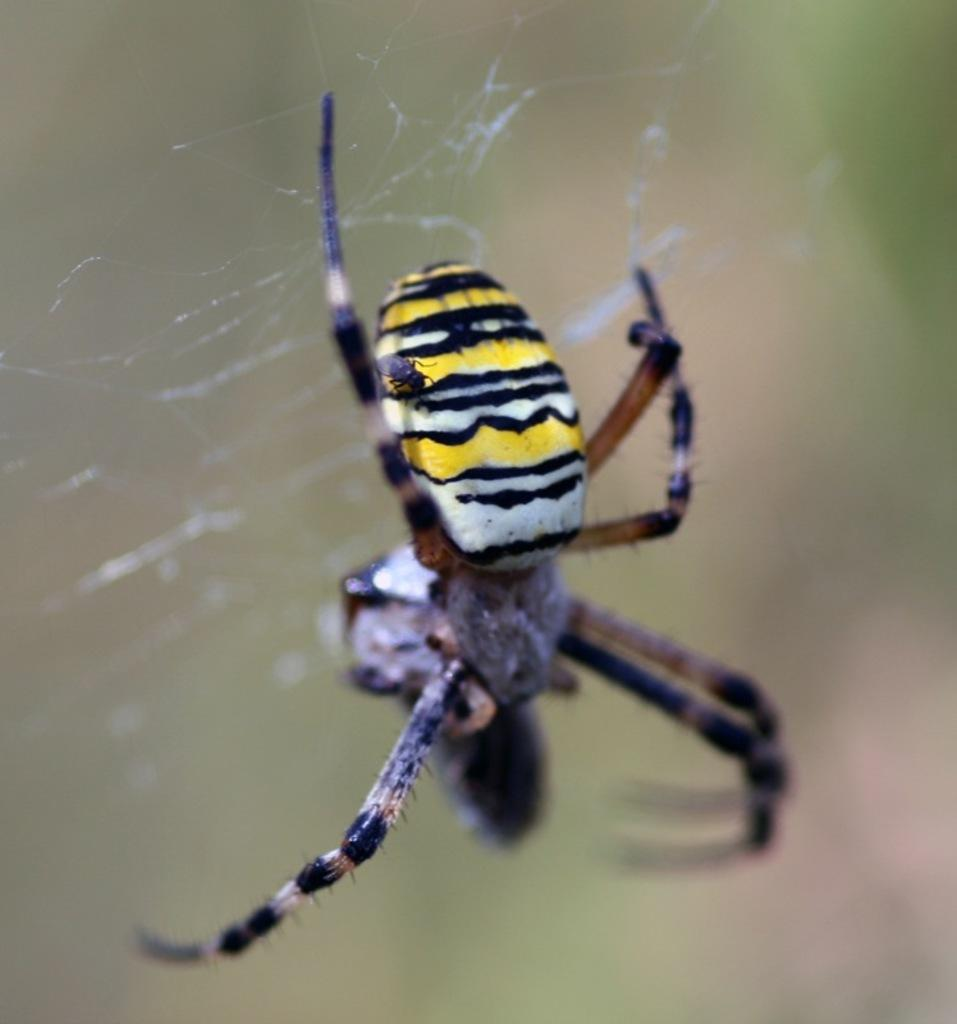What is the main subject of the image? There is a spider in the center of the image. What is the spider associated with in the image? There is a spider web in the image. Can you describe the background of the image? The background of the image is blurred. What type of noise can be heard coming from the spider in the image? There is no sound associated with the spider in the image, so it cannot be determined what type of noise might be heard. 